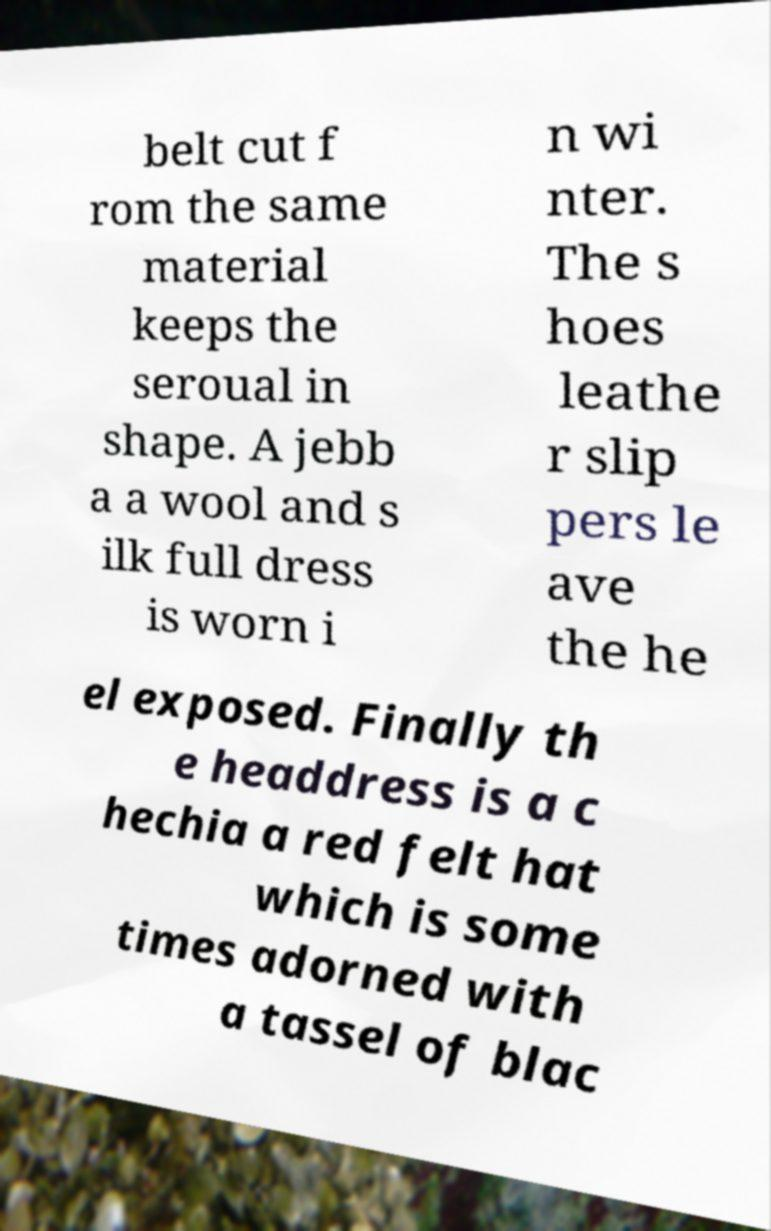For documentation purposes, I need the text within this image transcribed. Could you provide that? belt cut f rom the same material keeps the seroual in shape. A jebb a a wool and s ilk full dress is worn i n wi nter. The s hoes leathe r slip pers le ave the he el exposed. Finally th e headdress is a c hechia a red felt hat which is some times adorned with a tassel of blac 